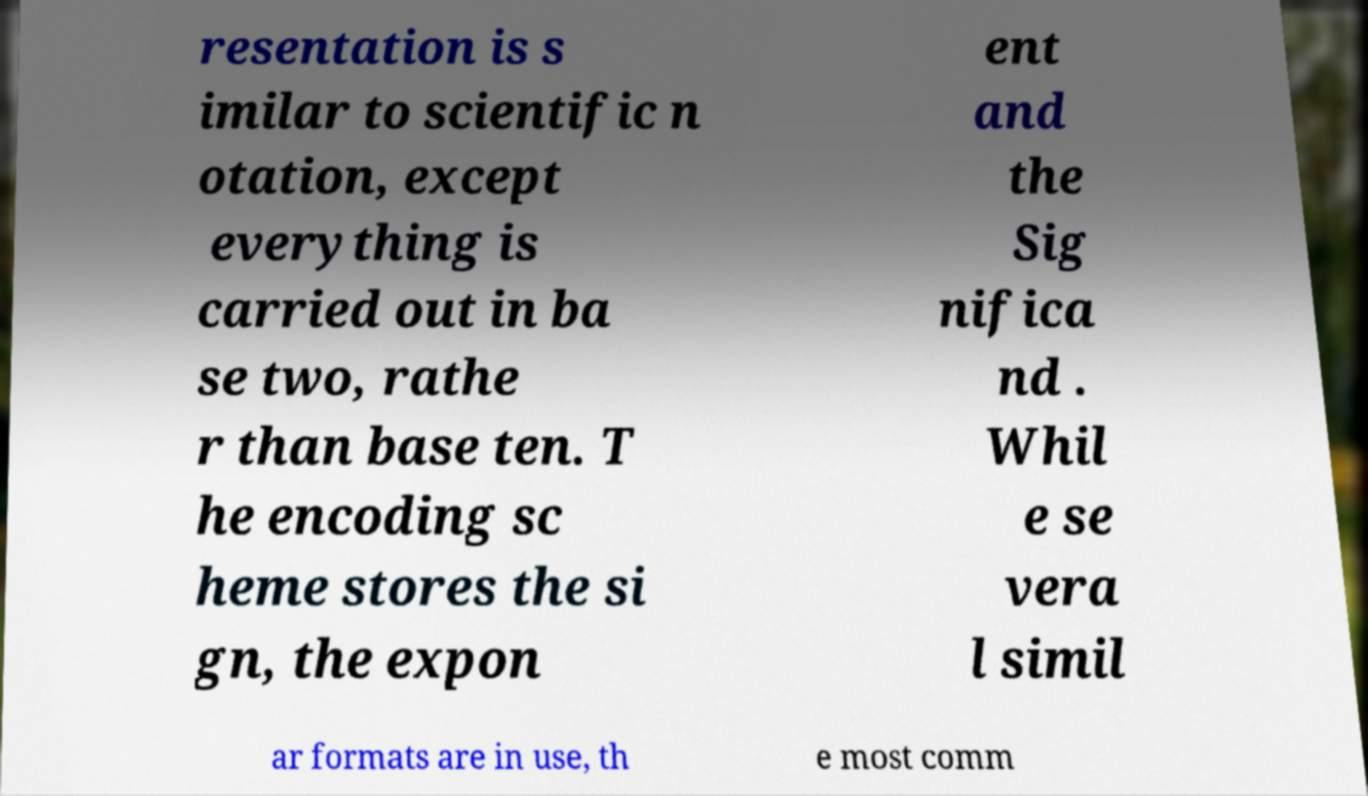There's text embedded in this image that I need extracted. Can you transcribe it verbatim? resentation is s imilar to scientific n otation, except everything is carried out in ba se two, rathe r than base ten. T he encoding sc heme stores the si gn, the expon ent and the Sig nifica nd . Whil e se vera l simil ar formats are in use, th e most comm 